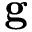Convert formula to latex. <formula><loc_0><loc_0><loc_500><loc_500>g</formula> 